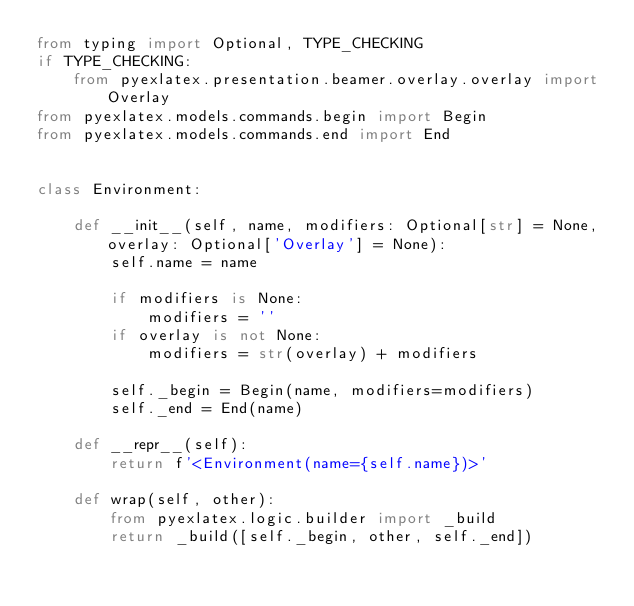<code> <loc_0><loc_0><loc_500><loc_500><_Python_>from typing import Optional, TYPE_CHECKING
if TYPE_CHECKING:
    from pyexlatex.presentation.beamer.overlay.overlay import Overlay
from pyexlatex.models.commands.begin import Begin
from pyexlatex.models.commands.end import End


class Environment:

    def __init__(self, name, modifiers: Optional[str] = None, overlay: Optional['Overlay'] = None):
        self.name = name

        if modifiers is None:
            modifiers = ''
        if overlay is not None:
            modifiers = str(overlay) + modifiers

        self._begin = Begin(name, modifiers=modifiers)
        self._end = End(name)

    def __repr__(self):
        return f'<Environment(name={self.name})>'

    def wrap(self, other):
        from pyexlatex.logic.builder import _build
        return _build([self._begin, other, self._end])
</code> 